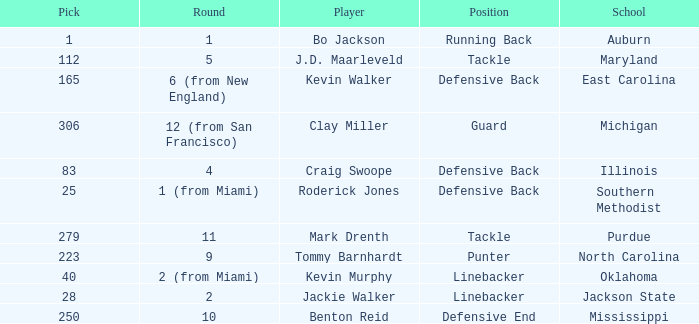What was the highest guard picked? 306.0. 